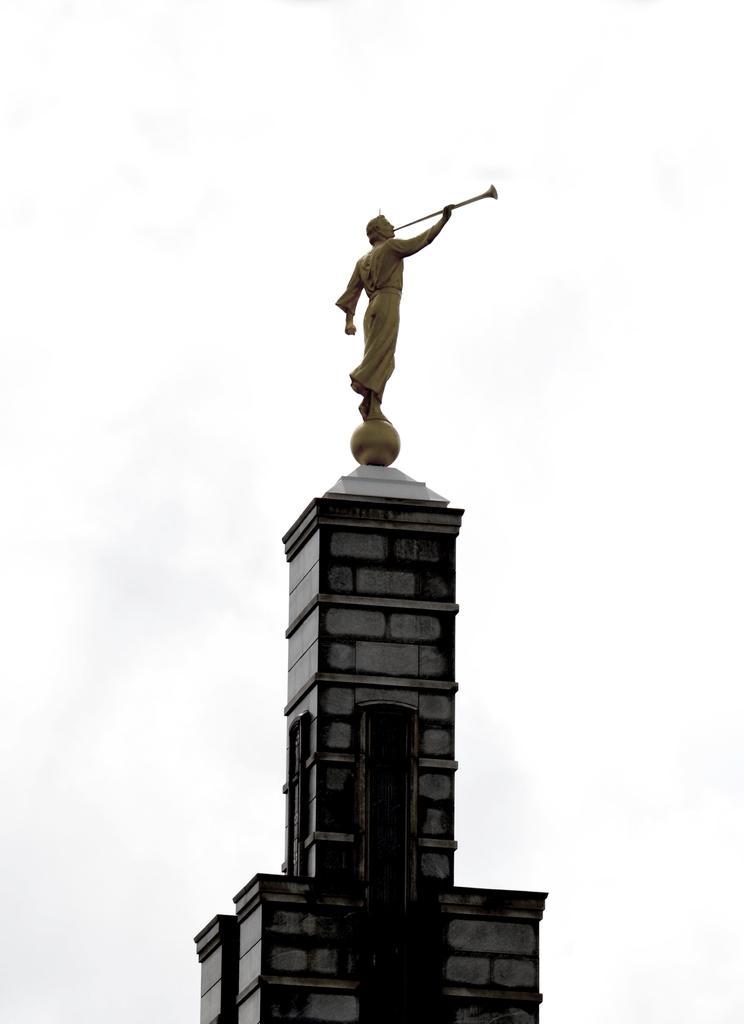Could you give a brief overview of what you see in this image? In this picture we can see a person statue on this monument building. On the background we can see sky and clouds. 